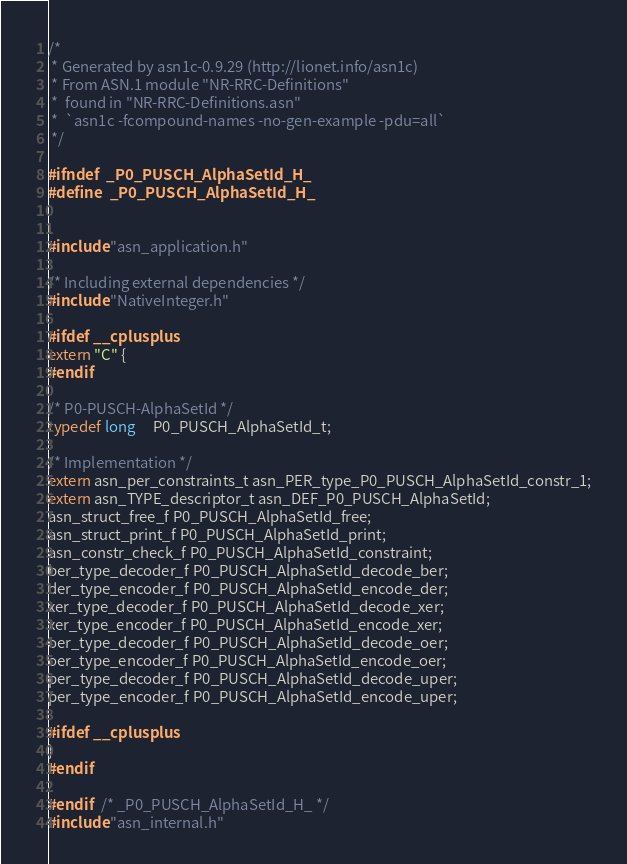Convert code to text. <code><loc_0><loc_0><loc_500><loc_500><_C_>/*
 * Generated by asn1c-0.9.29 (http://lionet.info/asn1c)
 * From ASN.1 module "NR-RRC-Definitions"
 * 	found in "NR-RRC-Definitions.asn"
 * 	`asn1c -fcompound-names -no-gen-example -pdu=all`
 */

#ifndef	_P0_PUSCH_AlphaSetId_H_
#define	_P0_PUSCH_AlphaSetId_H_


#include "asn_application.h"

/* Including external dependencies */
#include "NativeInteger.h"

#ifdef __cplusplus
extern "C" {
#endif

/* P0-PUSCH-AlphaSetId */
typedef long	 P0_PUSCH_AlphaSetId_t;

/* Implementation */
extern asn_per_constraints_t asn_PER_type_P0_PUSCH_AlphaSetId_constr_1;
extern asn_TYPE_descriptor_t asn_DEF_P0_PUSCH_AlphaSetId;
asn_struct_free_f P0_PUSCH_AlphaSetId_free;
asn_struct_print_f P0_PUSCH_AlphaSetId_print;
asn_constr_check_f P0_PUSCH_AlphaSetId_constraint;
ber_type_decoder_f P0_PUSCH_AlphaSetId_decode_ber;
der_type_encoder_f P0_PUSCH_AlphaSetId_encode_der;
xer_type_decoder_f P0_PUSCH_AlphaSetId_decode_xer;
xer_type_encoder_f P0_PUSCH_AlphaSetId_encode_xer;
oer_type_decoder_f P0_PUSCH_AlphaSetId_decode_oer;
oer_type_encoder_f P0_PUSCH_AlphaSetId_encode_oer;
per_type_decoder_f P0_PUSCH_AlphaSetId_decode_uper;
per_type_encoder_f P0_PUSCH_AlphaSetId_encode_uper;

#ifdef __cplusplus
}
#endif

#endif	/* _P0_PUSCH_AlphaSetId_H_ */
#include "asn_internal.h"
</code> 